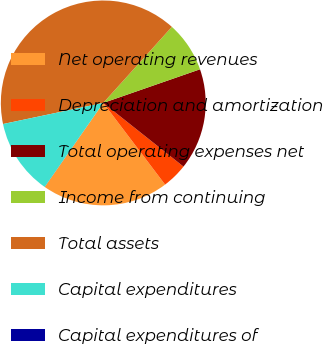<chart> <loc_0><loc_0><loc_500><loc_500><pie_chart><fcel>Net operating revenues<fcel>Depreciation and amortization<fcel>Total operating expenses net<fcel>Income from continuing<fcel>Total assets<fcel>Capital expenditures<fcel>Capital expenditures of<nl><fcel>20.0%<fcel>4.01%<fcel>16.0%<fcel>8.0%<fcel>39.98%<fcel>12.0%<fcel>0.01%<nl></chart> 